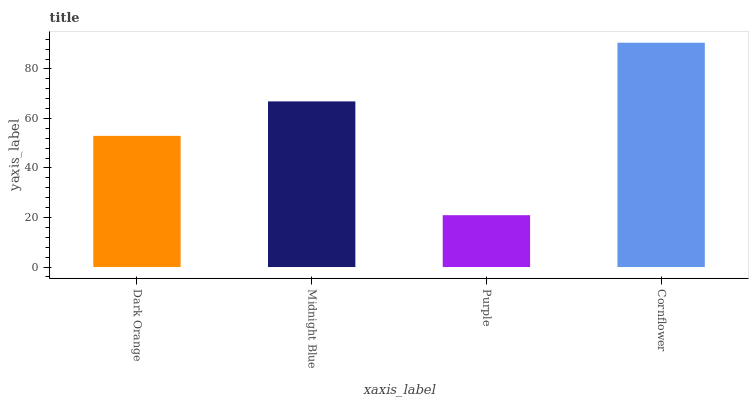Is Midnight Blue the minimum?
Answer yes or no. No. Is Midnight Blue the maximum?
Answer yes or no. No. Is Midnight Blue greater than Dark Orange?
Answer yes or no. Yes. Is Dark Orange less than Midnight Blue?
Answer yes or no. Yes. Is Dark Orange greater than Midnight Blue?
Answer yes or no. No. Is Midnight Blue less than Dark Orange?
Answer yes or no. No. Is Midnight Blue the high median?
Answer yes or no. Yes. Is Dark Orange the low median?
Answer yes or no. Yes. Is Cornflower the high median?
Answer yes or no. No. Is Cornflower the low median?
Answer yes or no. No. 